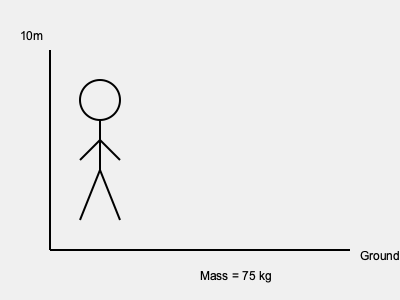As a stuntman preparing for a dramatic fall scene, you need to calculate the impact force on your body. Given that you weigh 75 kg and will fall from a height of 10 meters onto a padded surface that allows for 0.5 meters of deceleration, what is the average impact force you will experience? Assume gravity is 9.8 m/s² and neglect air resistance. To calculate the average impact force, we'll follow these steps:

1. Calculate the initial velocity at impact:
   Using the equation $v^2 = u^2 + 2as$, where $u = 0$ (starting from rest):
   $v^2 = 0 + 2(9.8)(10)$
   $v = \sqrt{196} = 14$ m/s

2. Calculate the deceleration:
   Using $v^2 = u^2 + 2as$, where $v = 0$ (final velocity):
   $0 = 14^2 + 2a(0.5)$
   $a = -\frac{14^2}{1} = -196$ m/s²

3. Apply Newton's Second Law:
   $F = ma$
   $F = 75 \times 196 = 14,700$ N

Therefore, the average impact force is 14,700 N or approximately 14.7 kN.

Note: This calculation assumes a constant deceleration, which is a simplification of the actual scenario. In reality, the force would vary throughout the impact.
Answer: 14.7 kN 